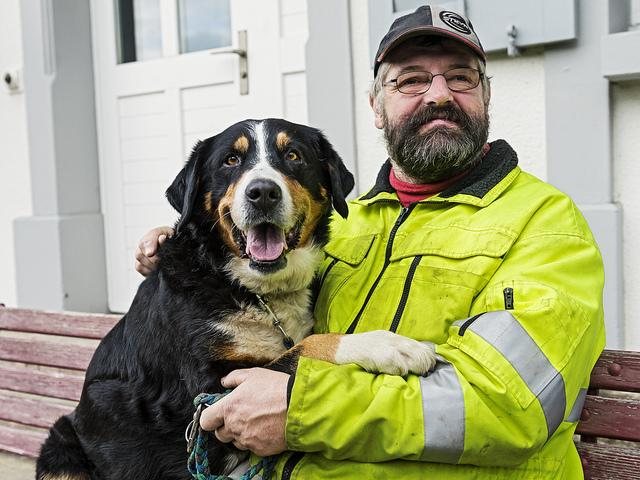What breed is the dog?
Keep it brief. Collie. What color is the man's coat?
Be succinct. Green. Is this person wearing glasses?
Concise answer only. Yes. 